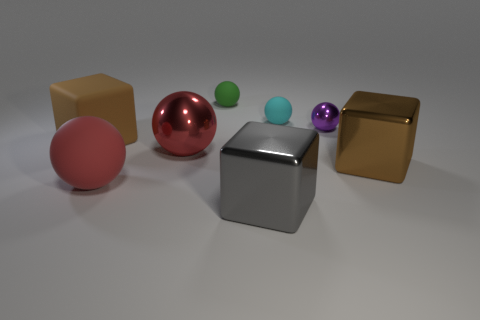Subtract 2 balls. How many balls are left? 3 Subtract all red spheres. How many spheres are left? 3 Subtract all big metal blocks. How many blocks are left? 1 Add 1 purple metallic things. How many objects exist? 9 Subtract all purple spheres. Subtract all brown cylinders. How many spheres are left? 4 Subtract all balls. How many objects are left? 3 Add 7 red cylinders. How many red cylinders exist? 7 Subtract 0 green cylinders. How many objects are left? 8 Subtract all green matte things. Subtract all small purple shiny spheres. How many objects are left? 6 Add 6 small cyan objects. How many small cyan objects are left? 7 